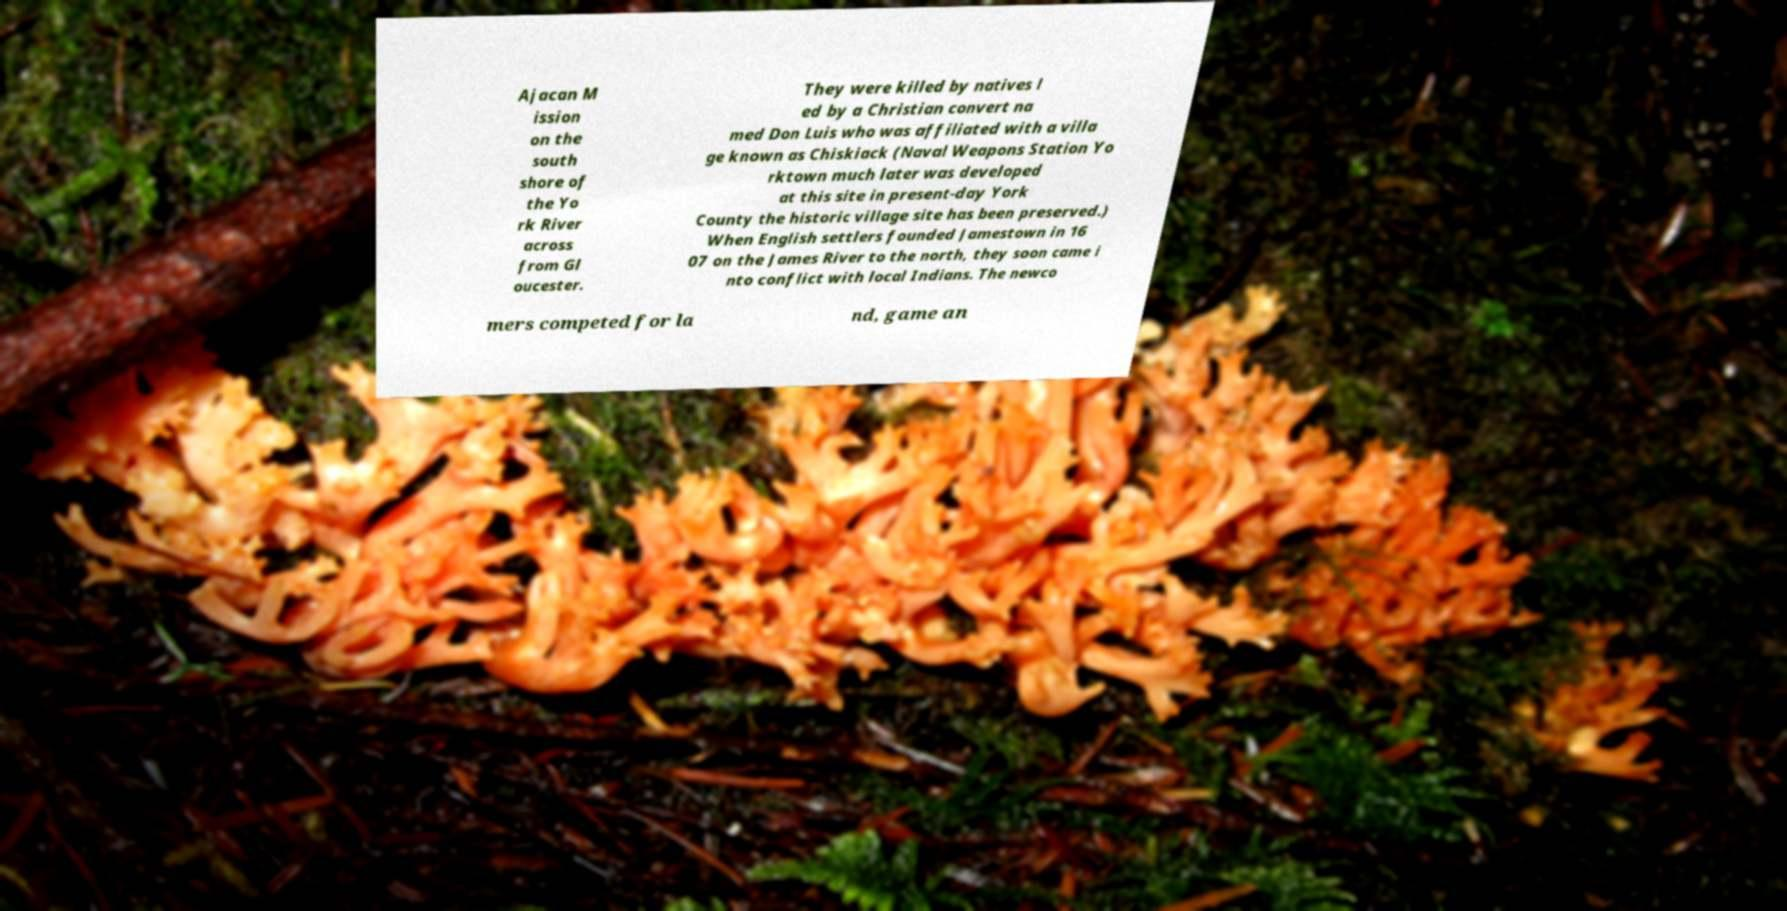Can you read and provide the text displayed in the image?This photo seems to have some interesting text. Can you extract and type it out for me? Ajacan M ission on the south shore of the Yo rk River across from Gl oucester. They were killed by natives l ed by a Christian convert na med Don Luis who was affiliated with a villa ge known as Chiskiack (Naval Weapons Station Yo rktown much later was developed at this site in present-day York County the historic village site has been preserved.) When English settlers founded Jamestown in 16 07 on the James River to the north, they soon came i nto conflict with local Indians. The newco mers competed for la nd, game an 